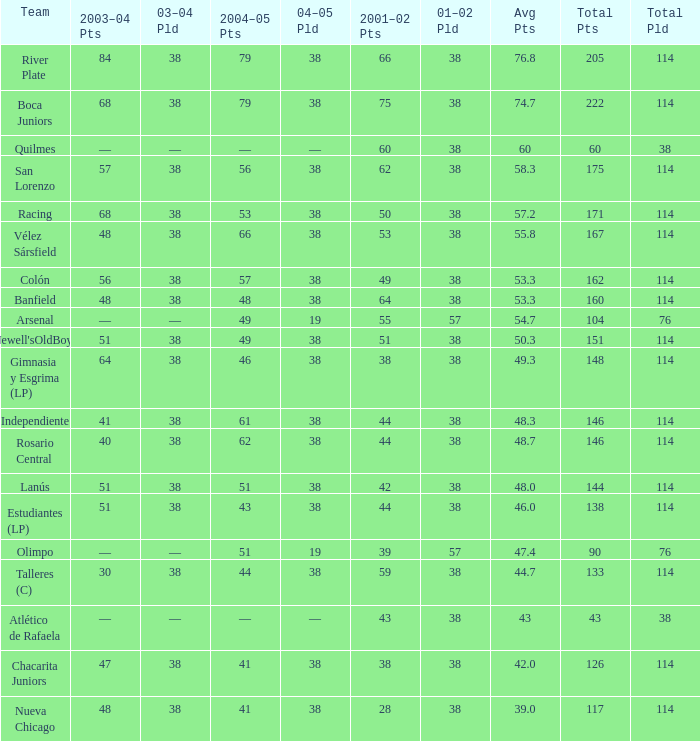Which Team has a Total Pld smaller than 114, and a 2004–05 Pts of 49? Arsenal. 